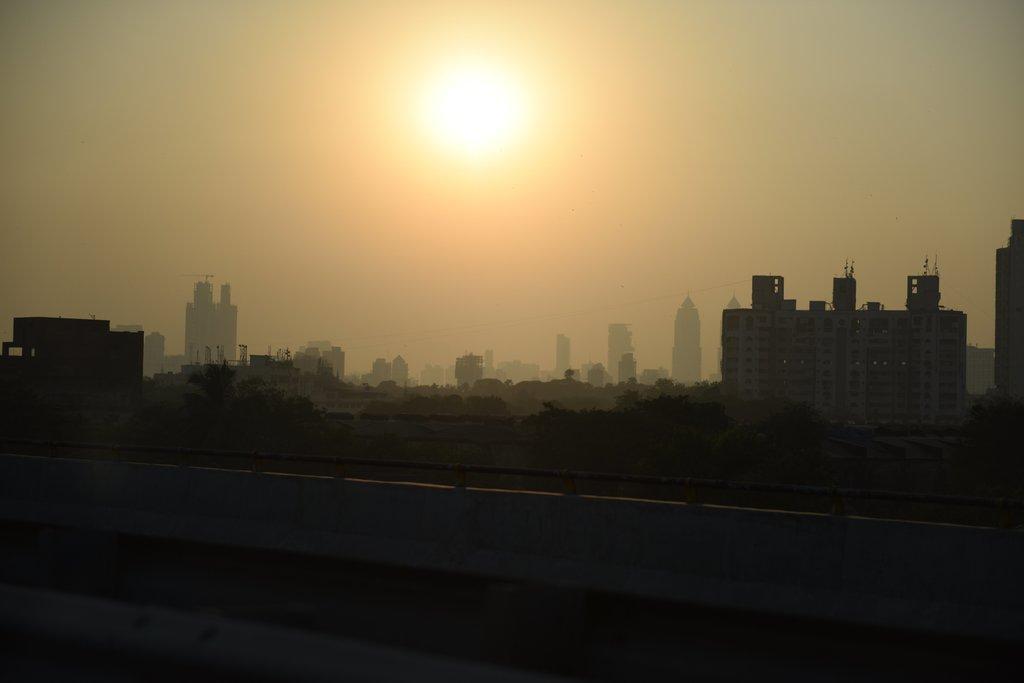Can you describe this image briefly? In this image, in the background, we can see some trees, buildings, rotator. At the top, we can see a sun, at the bottom, we can see black color. 